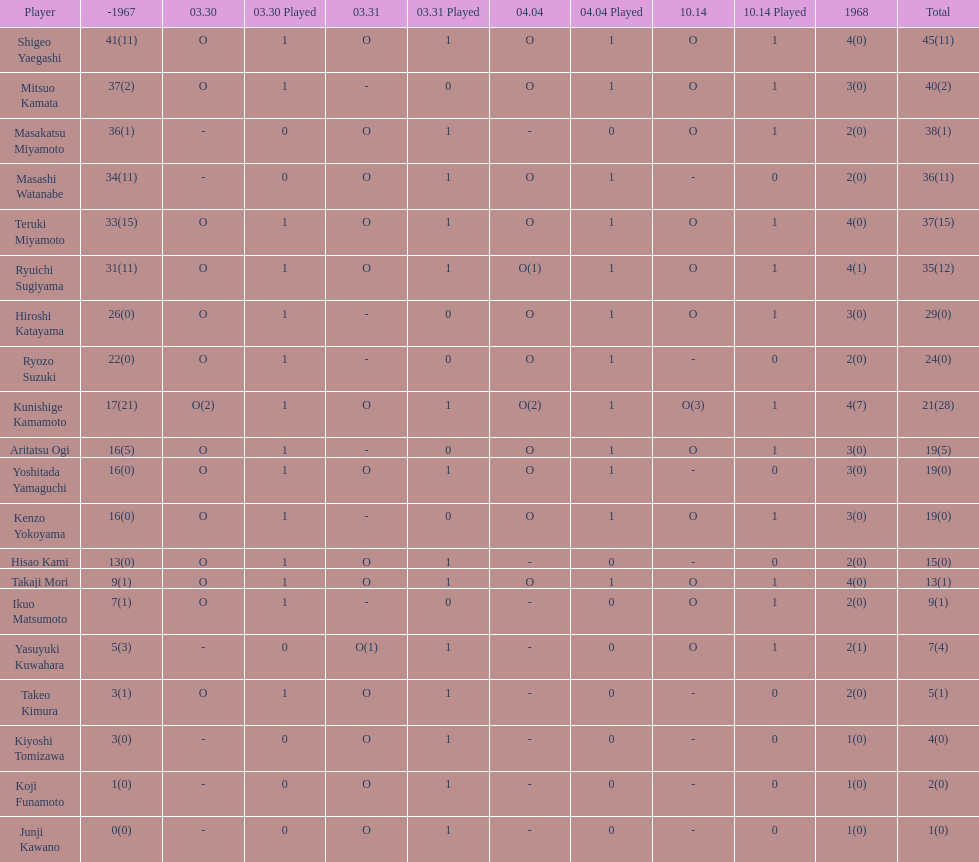How many total did mitsuo kamata have? 40(2). 